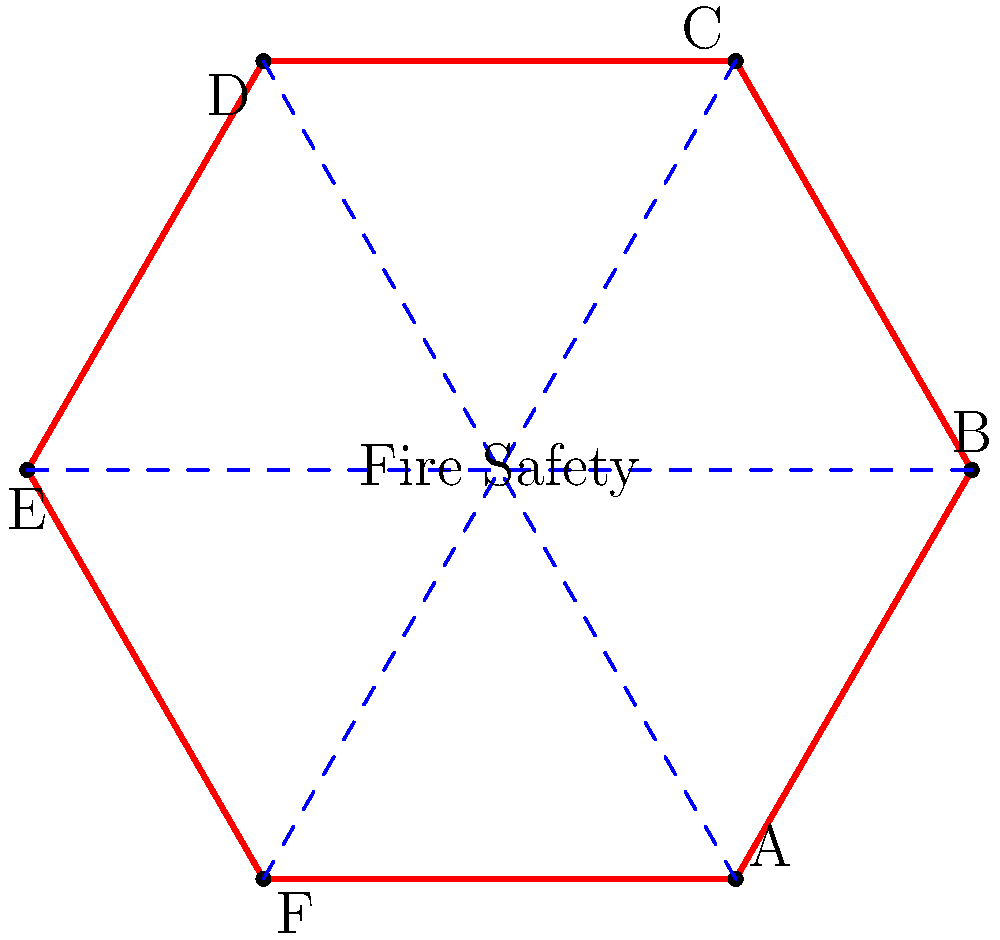A hexagonal fire safety poster has been designed with three lines of symmetry as shown in the diagram. How many elements are in the dihedral group that represents all possible symmetries of this poster design, and what are these elements? To determine the elements of the dihedral group for this hexagonal fire safety poster, we need to consider all possible symmetries:

1. Rotational symmetries:
   - Identity (0° rotation)
   - 60° rotation clockwise
   - 120° rotation clockwise
   - 180° rotation
   - 240° rotation clockwise (120° counterclockwise)
   - 300° rotation clockwise (60° counterclockwise)

2. Reflection symmetries:
   - Reflection across the line AD
   - Reflection across the line BE
   - Reflection across the line CF

The dihedral group $D_6$ represents these symmetries. The order of this group is calculated as follows:

$|D_6| = 2n$, where $n$ is the number of sides in the polygon.
$|D_6| = 2 * 6 = 12$

Therefore, there are 12 elements in the dihedral group representing all possible symmetries of this poster design.

The elements can be represented as:
- $e$ (identity)
- $r, r^2, r^3, r^4, r^5$ (rotations)
- $s, sr, sr^2, sr^3, sr^4, sr^5$ (reflections)

Where $r$ represents a 60° rotation clockwise, and $s$ represents a reflection across one of the axes of symmetry.
Answer: 12 elements: $e, r, r^2, r^3, r^4, r^5, s, sr, sr^2, sr^3, sr^4, sr^5$ 